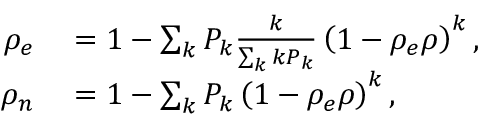Convert formula to latex. <formula><loc_0><loc_0><loc_500><loc_500>\begin{array} { r l } { \rho _ { e } } & = 1 - \sum _ { k } P _ { k } \frac { k } { \sum _ { k } k P _ { k } } \left ( 1 - \rho _ { e } \rho \right ) ^ { k } , } \\ { \rho _ { n } } & = 1 - \sum _ { k } P _ { k } \left ( 1 - \rho _ { e } \rho \right ) ^ { k } , } \end{array}</formula> 